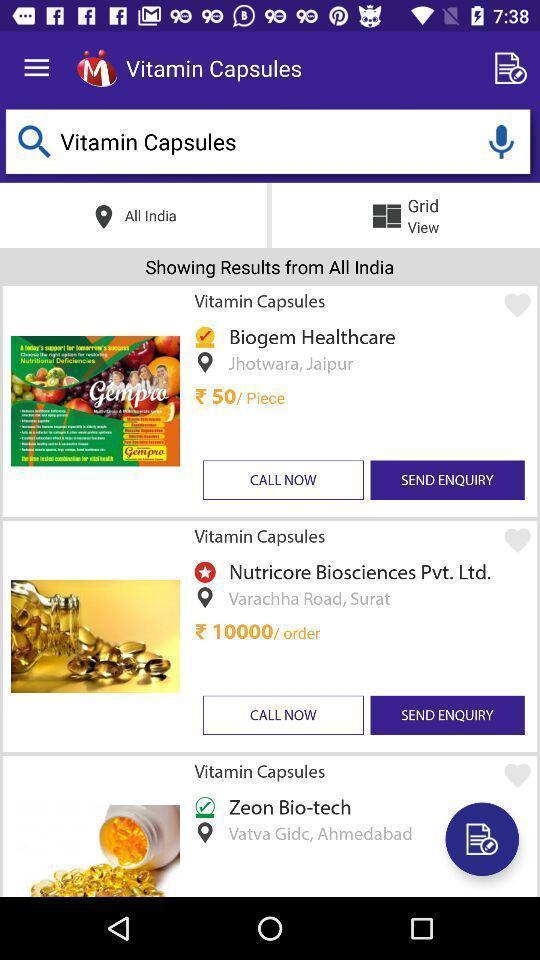What can you discern from this picture? Screen shows list of capsules in a shopping app. 